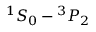Convert formula to latex. <formula><loc_0><loc_0><loc_500><loc_500>{ } ^ { 1 } S _ { 0 } ^ { 3 } P _ { 2 }</formula> 